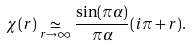<formula> <loc_0><loc_0><loc_500><loc_500>\chi ( r ) \underset { r \rightarrow \infty } { \simeq } \frac { \sin ( \pi \alpha ) } { \pi \alpha } ( i \pi + r ) .</formula> 